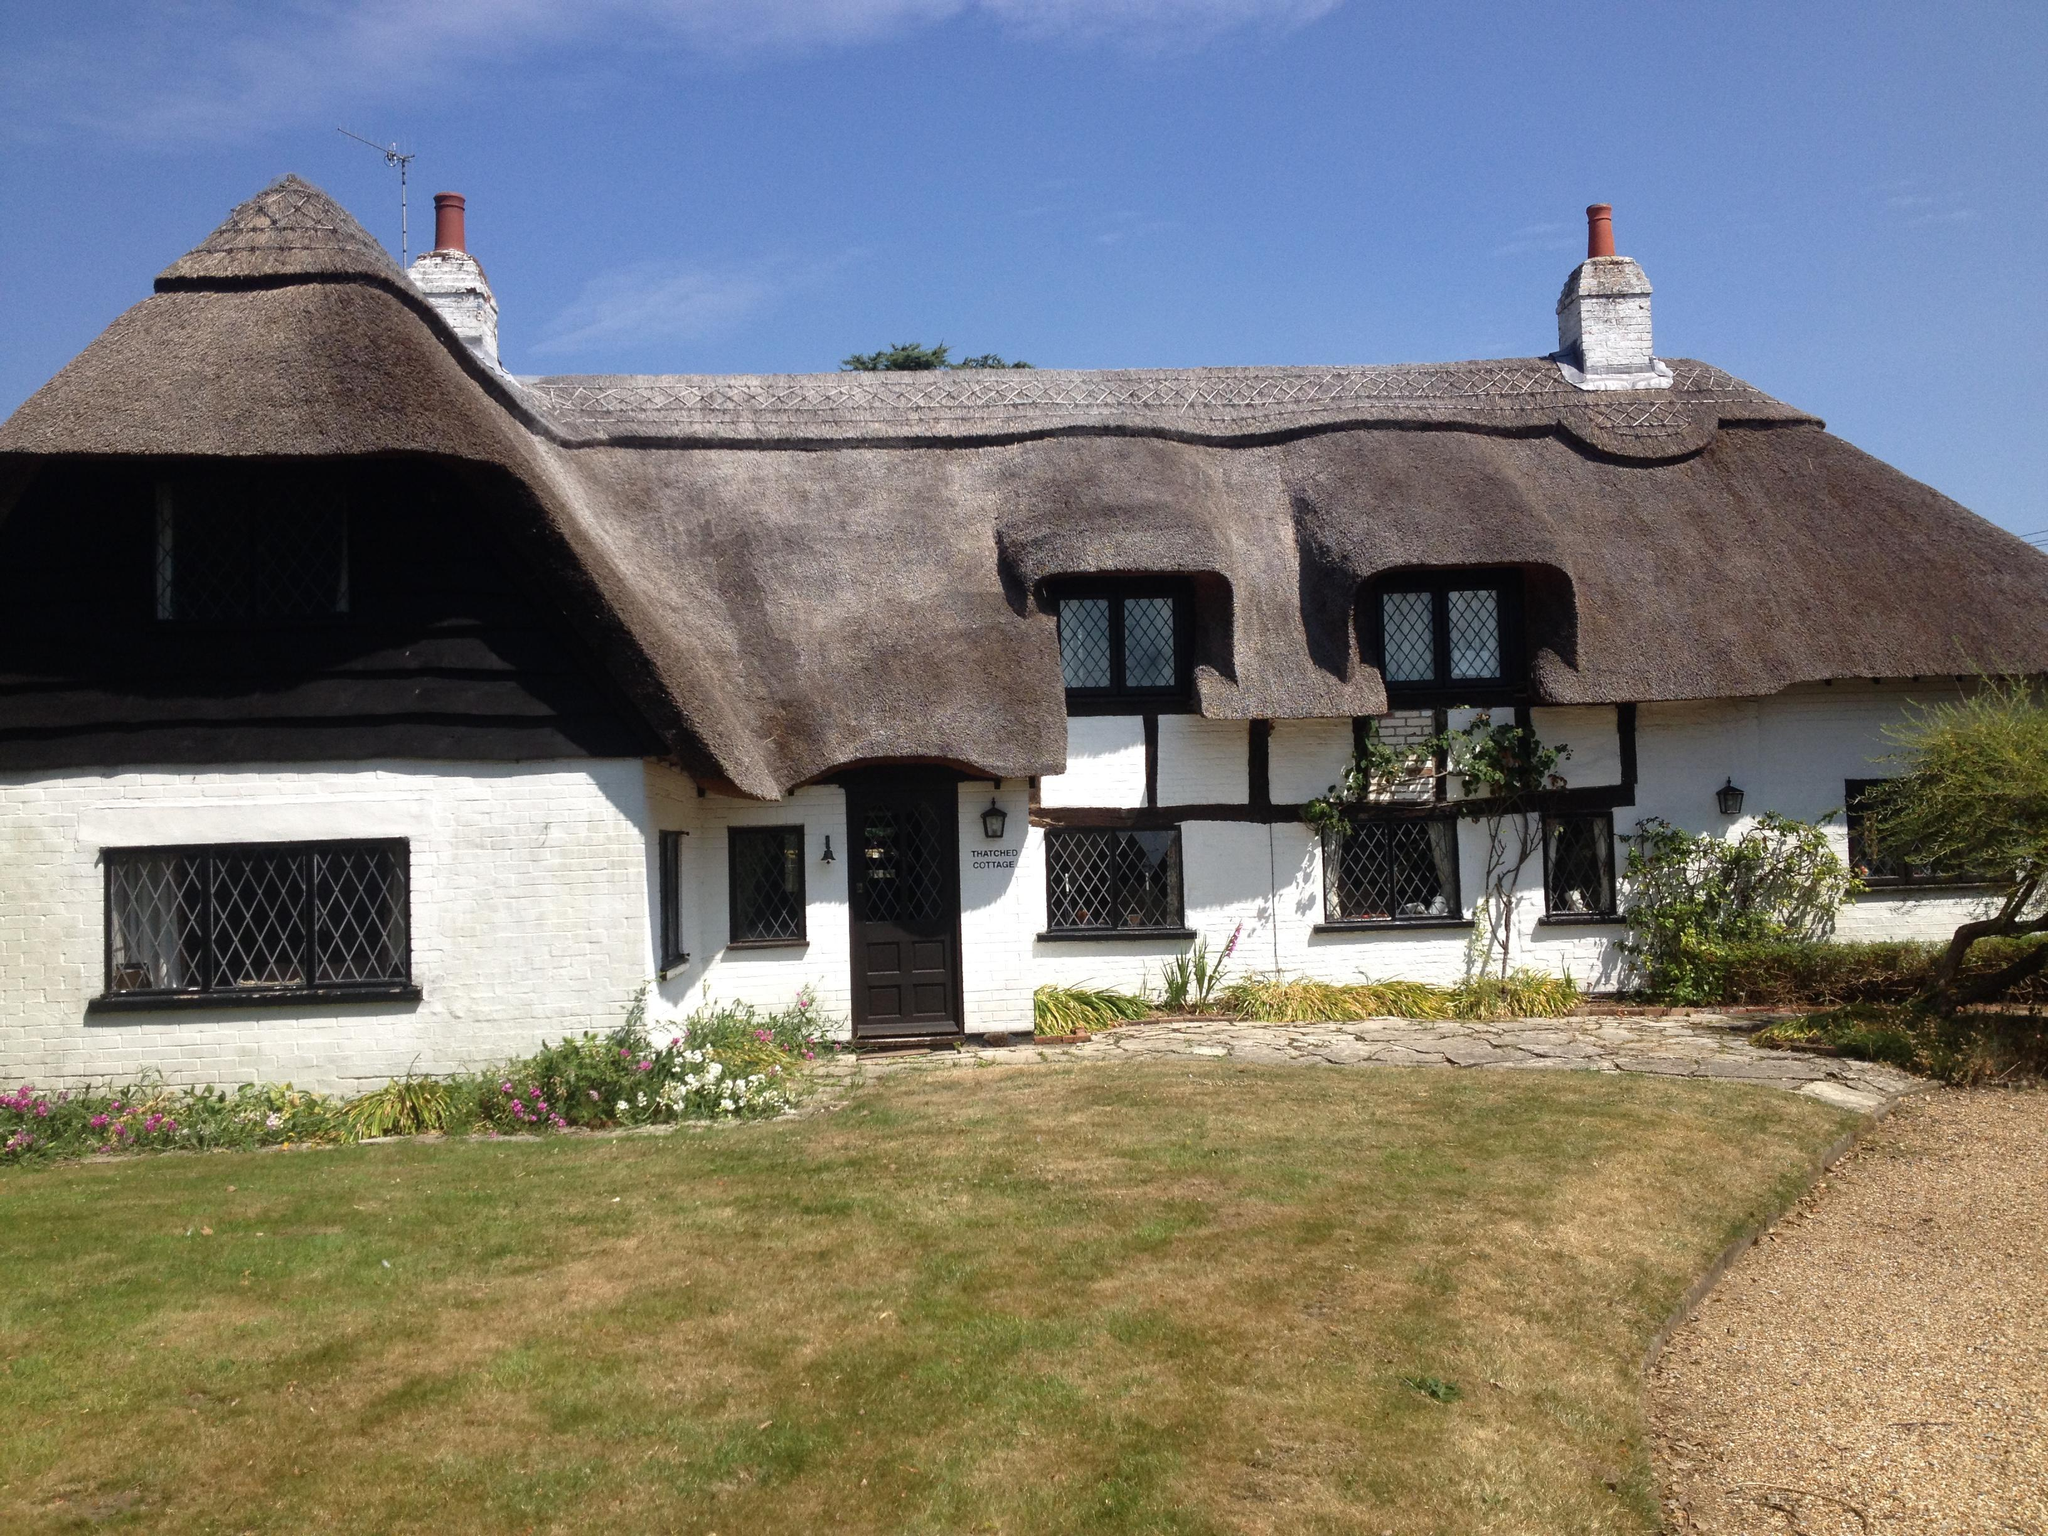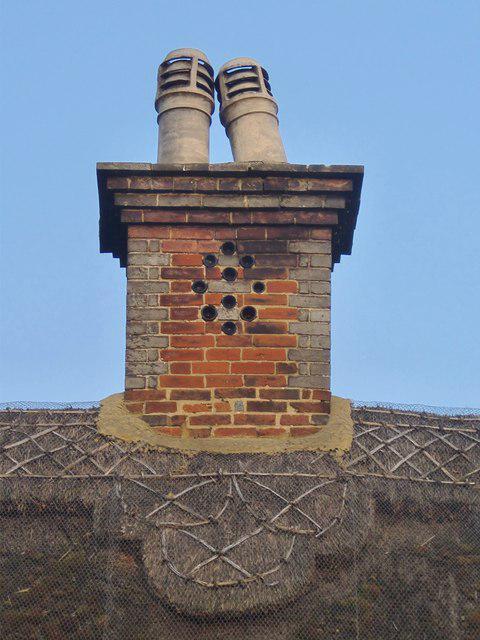The first image is the image on the left, the second image is the image on the right. Evaluate the accuracy of this statement regarding the images: "One of the houses has two chimneys.". Is it true? Answer yes or no. Yes. 